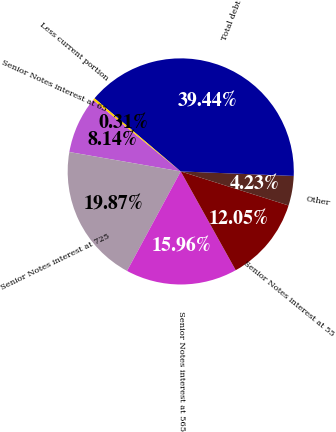<chart> <loc_0><loc_0><loc_500><loc_500><pie_chart><fcel>Senior Notes interest at 65<fcel>Senior Notes interest at 725<fcel>Senior Notes interest at 565<fcel>Senior Notes interest at 55<fcel>Other<fcel>Total debt<fcel>Less current portion<nl><fcel>8.14%<fcel>19.87%<fcel>15.96%<fcel>12.05%<fcel>4.23%<fcel>39.44%<fcel>0.31%<nl></chart> 